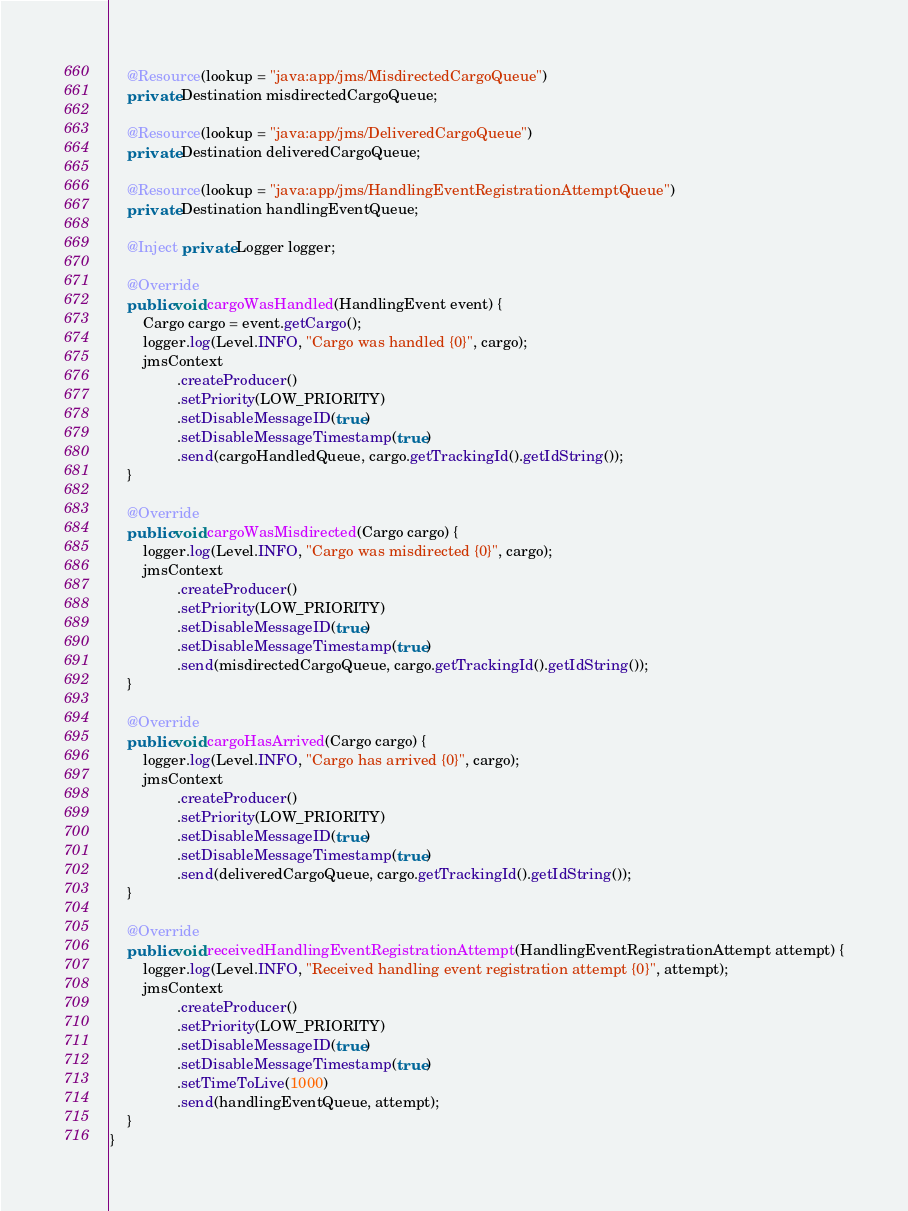Convert code to text. <code><loc_0><loc_0><loc_500><loc_500><_Java_>
    @Resource(lookup = "java:app/jms/MisdirectedCargoQueue")
    private Destination misdirectedCargoQueue;

    @Resource(lookup = "java:app/jms/DeliveredCargoQueue")
    private Destination deliveredCargoQueue;

    @Resource(lookup = "java:app/jms/HandlingEventRegistrationAttemptQueue")
    private Destination handlingEventQueue;

    @Inject private Logger logger;

    @Override
    public void cargoWasHandled(HandlingEvent event) {
        Cargo cargo = event.getCargo();
        logger.log(Level.INFO, "Cargo was handled {0}", cargo);
        jmsContext
                .createProducer()
                .setPriority(LOW_PRIORITY)
                .setDisableMessageID(true)
                .setDisableMessageTimestamp(true)
                .send(cargoHandledQueue, cargo.getTrackingId().getIdString());
    }

    @Override
    public void cargoWasMisdirected(Cargo cargo) {
        logger.log(Level.INFO, "Cargo was misdirected {0}", cargo);
        jmsContext
                .createProducer()
                .setPriority(LOW_PRIORITY)
                .setDisableMessageID(true)
                .setDisableMessageTimestamp(true)
                .send(misdirectedCargoQueue, cargo.getTrackingId().getIdString());
    }

    @Override
    public void cargoHasArrived(Cargo cargo) {
        logger.log(Level.INFO, "Cargo has arrived {0}", cargo);
        jmsContext
                .createProducer()
                .setPriority(LOW_PRIORITY)
                .setDisableMessageID(true)
                .setDisableMessageTimestamp(true)
                .send(deliveredCargoQueue, cargo.getTrackingId().getIdString());
    }

    @Override
    public void receivedHandlingEventRegistrationAttempt(HandlingEventRegistrationAttempt attempt) {
        logger.log(Level.INFO, "Received handling event registration attempt {0}", attempt);
        jmsContext
                .createProducer()
                .setPriority(LOW_PRIORITY)
                .setDisableMessageID(true)
                .setDisableMessageTimestamp(true)
                .setTimeToLive(1000)
                .send(handlingEventQueue, attempt);
    }
}
</code> 